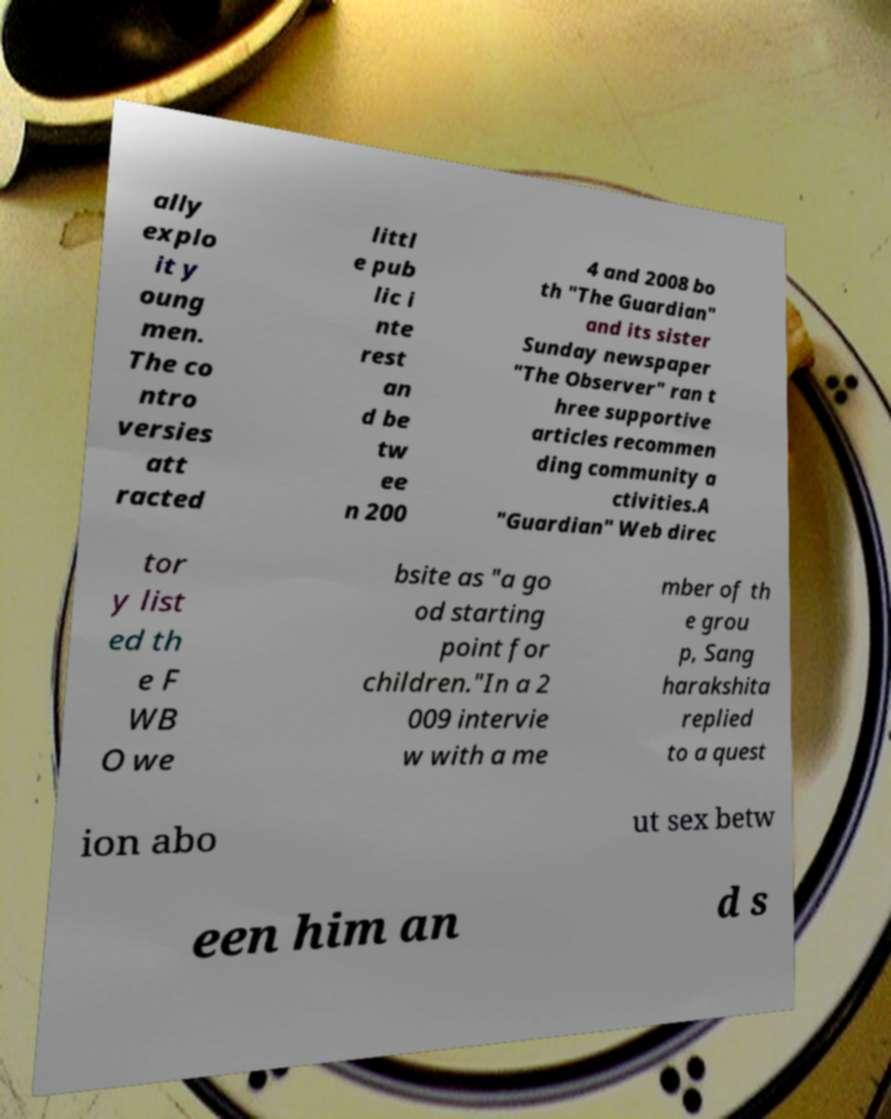Can you read and provide the text displayed in the image?This photo seems to have some interesting text. Can you extract and type it out for me? ally explo it y oung men. The co ntro versies att racted littl e pub lic i nte rest an d be tw ee n 200 4 and 2008 bo th "The Guardian" and its sister Sunday newspaper "The Observer" ran t hree supportive articles recommen ding community a ctivities.A "Guardian" Web direc tor y list ed th e F WB O we bsite as "a go od starting point for children."In a 2 009 intervie w with a me mber of th e grou p, Sang harakshita replied to a quest ion abo ut sex betw een him an d s 